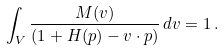Convert formula to latex. <formula><loc_0><loc_0><loc_500><loc_500>\int _ { V } \frac { M ( v ) } { ( 1 + H ( p ) - v \cdot p ) } \, d v = 1 \, .</formula> 